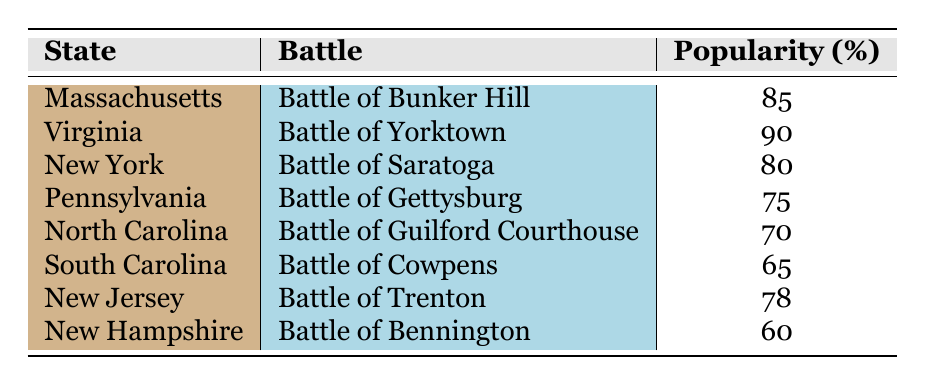What is the popularity percentage of the Battle of Yorktown in Virginia? The table indicates that in Virginia, the Battle of Yorktown has a popularity of 90%.
Answer: 90 Which battle is the least popular among the listed battles? By reviewing the popularity percentages, the Battle of Bennington in New Hampshire has the lowest score at 60%.
Answer: Battle of Bennington What state has the highest popularity rating for its battle, and what is that rating? Virginia shows the highest rating for the Battle of Yorktown at 90%. Therefore, the state with the highest popularity is Virginia, and the rating is 90%.
Answer: Virginia, 90 What is the average popularity percentage of battles in states where they are located? First, we sum the popularity percentages: 85 + 90 + 80 + 75 + 70 + 65 + 78 + 60 =  600. There are 8 battles, so the average popularity is 600 / 8 = 75.
Answer: 75 Is the Battle of Cowpens more popular than the Battle of Gettysburg in South Carolina and Pennsylvania respectively? The table shows that the Battle of Cowpens has a popularity rating of 65%, while the Battle of Gettysburg has a rating of 75%. Since 65% is less than 75%, Cowpens is not more popular.
Answer: No How many states have battles with a popularity rating above 75%? Reviewing the table shows that the battles in Massachusetts (85), Virginia (90), New York (80), and New Jersey (78) have ratings above 75%. Therefore, there are 4 states.
Answer: 4 Which battle in New Jersey has a popularity percentage closer to the average of all the battles? The average popularity calculated was 75. The Battle of Trenton has a popularity of 78%, which is closer to the average than any other listed new jersey battles.
Answer: Battle of Trenton What is the difference in popularity between the Battle of Guilford Courthouse and the Battle of Cowpens? The Battle of Guilford Courthouse has a popularity of 70%, and the Battle of Cowpens has 65%. The difference between them is 70 - 65 = 5%.
Answer: 5 